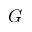<formula> <loc_0><loc_0><loc_500><loc_500>G</formula> 